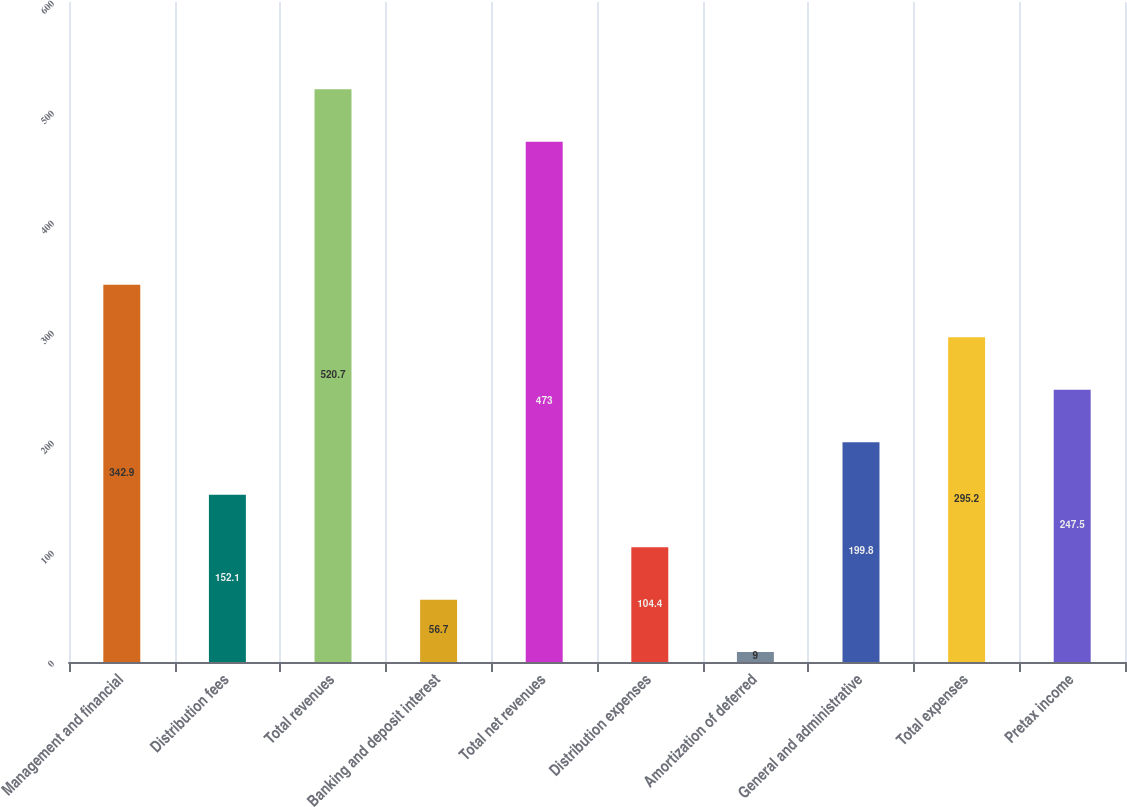Convert chart. <chart><loc_0><loc_0><loc_500><loc_500><bar_chart><fcel>Management and financial<fcel>Distribution fees<fcel>Total revenues<fcel>Banking and deposit interest<fcel>Total net revenues<fcel>Distribution expenses<fcel>Amortization of deferred<fcel>General and administrative<fcel>Total expenses<fcel>Pretax income<nl><fcel>342.9<fcel>152.1<fcel>520.7<fcel>56.7<fcel>473<fcel>104.4<fcel>9<fcel>199.8<fcel>295.2<fcel>247.5<nl></chart> 